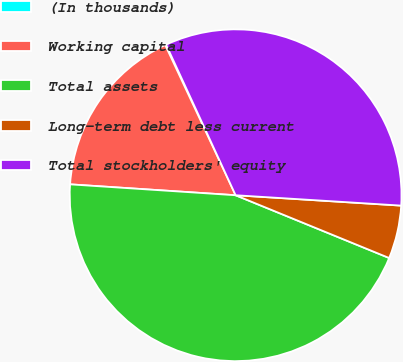Convert chart. <chart><loc_0><loc_0><loc_500><loc_500><pie_chart><fcel>(In thousands)<fcel>Working capital<fcel>Total assets<fcel>Long-term debt less current<fcel>Total stockholders' equity<nl><fcel>0.09%<fcel>16.98%<fcel>44.87%<fcel>5.18%<fcel>32.88%<nl></chart> 